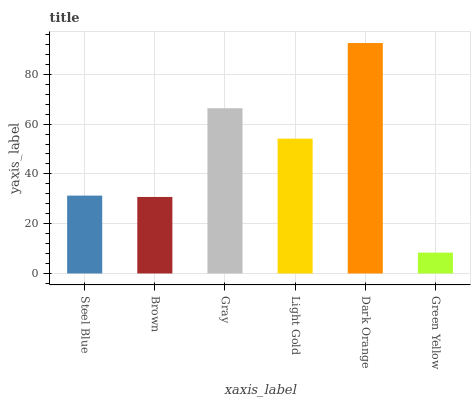Is Green Yellow the minimum?
Answer yes or no. Yes. Is Dark Orange the maximum?
Answer yes or no. Yes. Is Brown the minimum?
Answer yes or no. No. Is Brown the maximum?
Answer yes or no. No. Is Steel Blue greater than Brown?
Answer yes or no. Yes. Is Brown less than Steel Blue?
Answer yes or no. Yes. Is Brown greater than Steel Blue?
Answer yes or no. No. Is Steel Blue less than Brown?
Answer yes or no. No. Is Light Gold the high median?
Answer yes or no. Yes. Is Steel Blue the low median?
Answer yes or no. Yes. Is Steel Blue the high median?
Answer yes or no. No. Is Light Gold the low median?
Answer yes or no. No. 